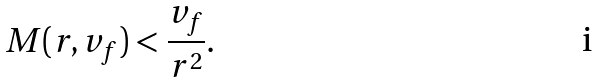<formula> <loc_0><loc_0><loc_500><loc_500>M ( r , v _ { f } ) < \frac { v _ { f } } { r ^ { 2 } } .</formula> 